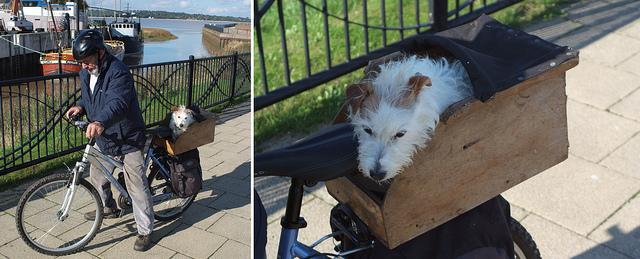Who placed this animal in the box? Please explain your reasoning. bike rider. The man that is riding the bike owns the dog and placed it in the box, 